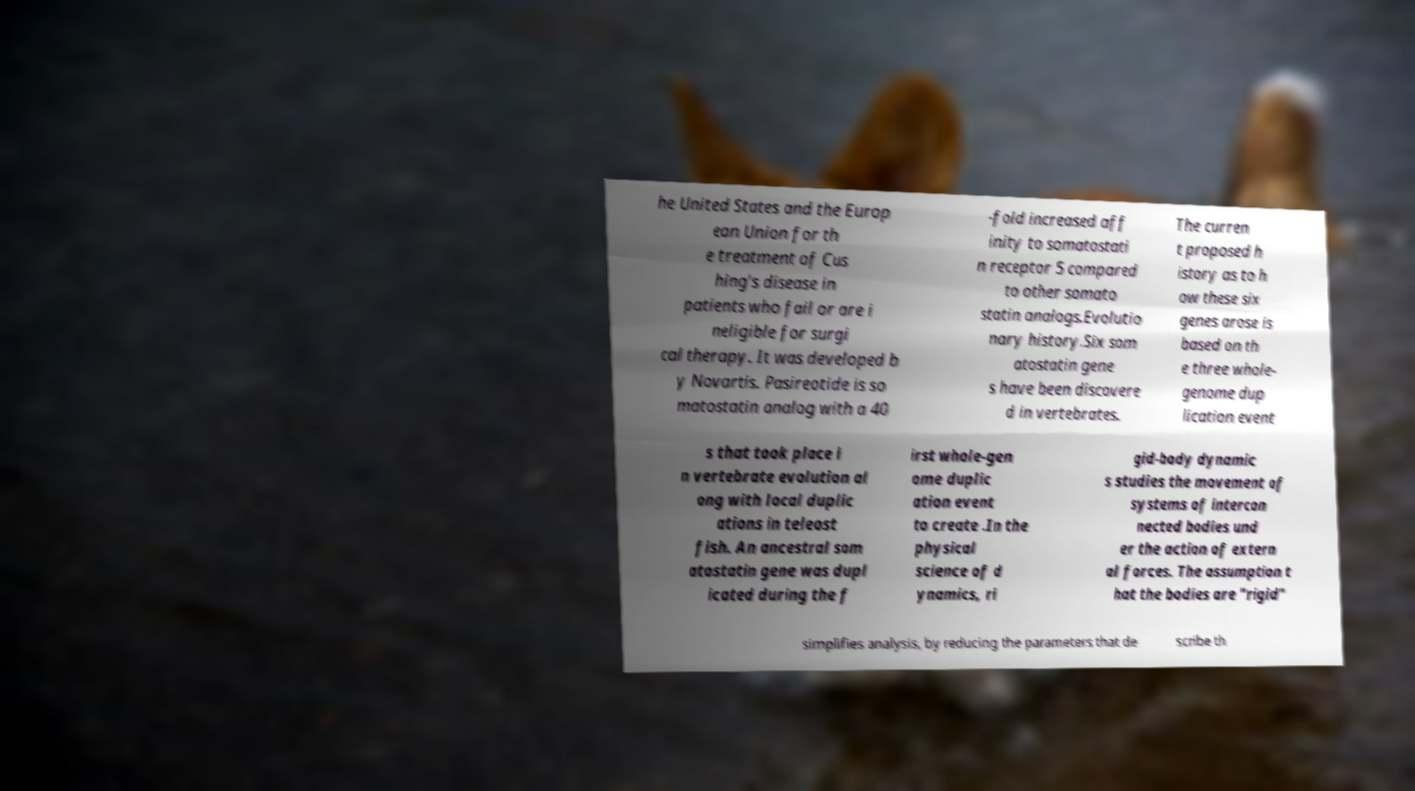There's text embedded in this image that I need extracted. Can you transcribe it verbatim? he United States and the Europ ean Union for th e treatment of Cus hing's disease in patients who fail or are i neligible for surgi cal therapy. It was developed b y Novartis. Pasireotide is so matostatin analog with a 40 -fold increased aff inity to somatostati n receptor 5 compared to other somato statin analogs.Evolutio nary history.Six som atostatin gene s have been discovere d in vertebrates. The curren t proposed h istory as to h ow these six genes arose is based on th e three whole- genome dup lication event s that took place i n vertebrate evolution al ong with local duplic ations in teleost fish. An ancestral som atostatin gene was dupl icated during the f irst whole-gen ome duplic ation event to create .In the physical science of d ynamics, ri gid-body dynamic s studies the movement of systems of intercon nected bodies und er the action of extern al forces. The assumption t hat the bodies are "rigid" simplifies analysis, by reducing the parameters that de scribe th 